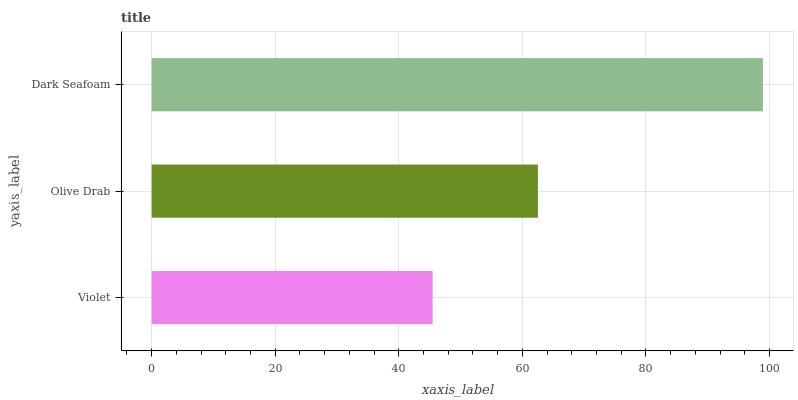Is Violet the minimum?
Answer yes or no. Yes. Is Dark Seafoam the maximum?
Answer yes or no. Yes. Is Olive Drab the minimum?
Answer yes or no. No. Is Olive Drab the maximum?
Answer yes or no. No. Is Olive Drab greater than Violet?
Answer yes or no. Yes. Is Violet less than Olive Drab?
Answer yes or no. Yes. Is Violet greater than Olive Drab?
Answer yes or no. No. Is Olive Drab less than Violet?
Answer yes or no. No. Is Olive Drab the high median?
Answer yes or no. Yes. Is Olive Drab the low median?
Answer yes or no. Yes. Is Dark Seafoam the high median?
Answer yes or no. No. Is Dark Seafoam the low median?
Answer yes or no. No. 